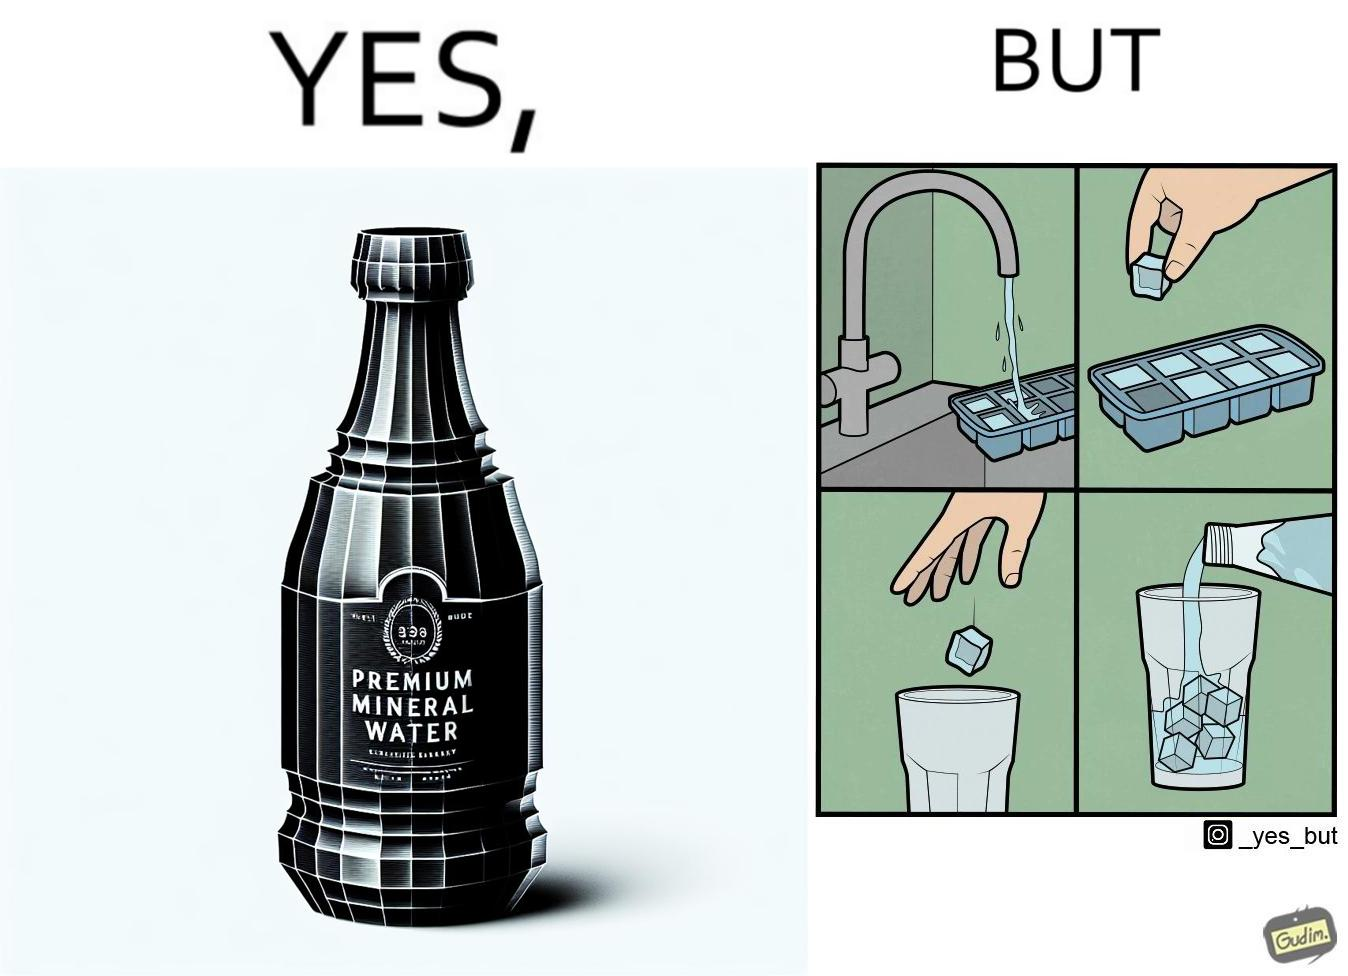What is shown in the left half versus the right half of this image? In the left part of the image: A bottle of "Premium Mineral Water". In the right part of the image: Pouring a bottle of water into a glass having ice cubes formed by refrigerating tap water. 